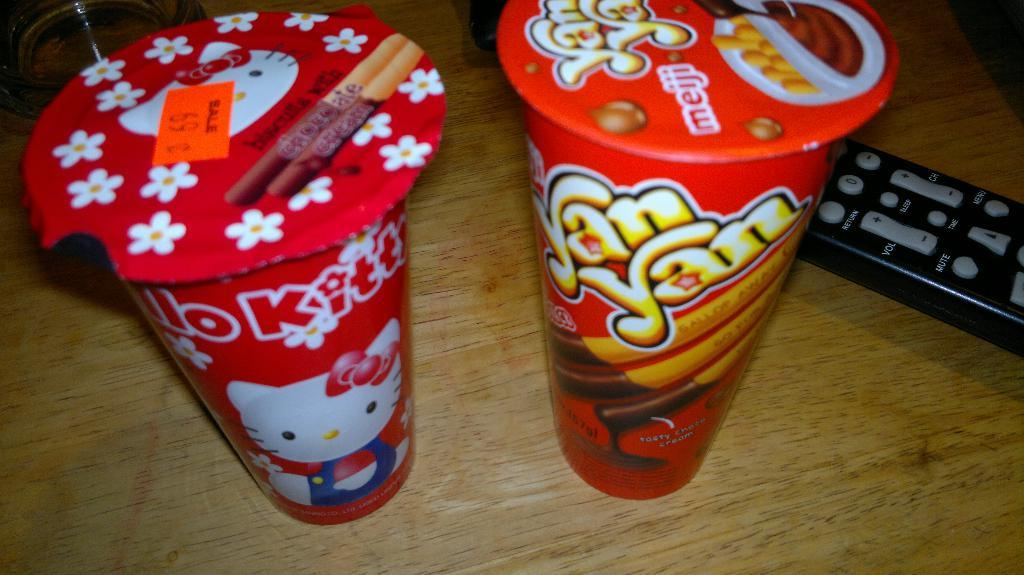<image>
Write a terse but informative summary of the picture. some pudding that has a yan yan phrase on it 